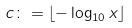<formula> <loc_0><loc_0><loc_500><loc_500>c \colon = \lfloor - \log _ { 1 0 } x \rfloor</formula> 